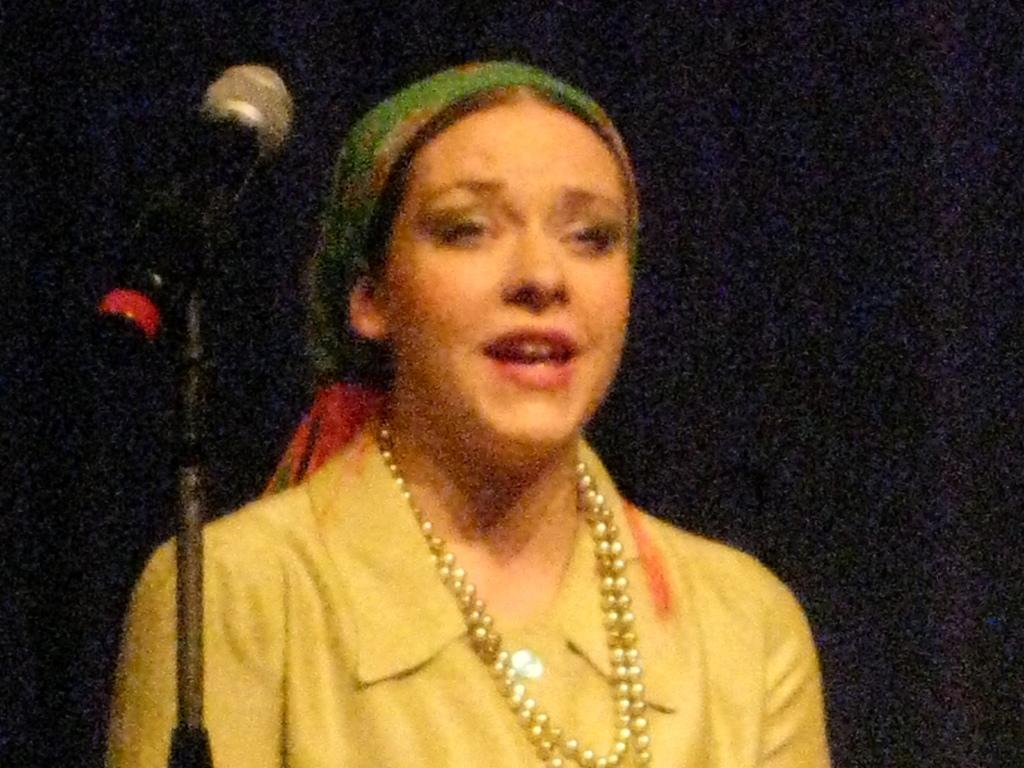Who or what is the main subject in the image? There is a person in the image. What object can be seen on the left side of the image? There is a microphone (mike) on the left side of the image. What color is the background of the image? The background of the image is black in color. What book is the person holding in the image? There is no book present in the image. What type of war is depicted in the background of the image? There is no war depicted in the image, as the background is black. 